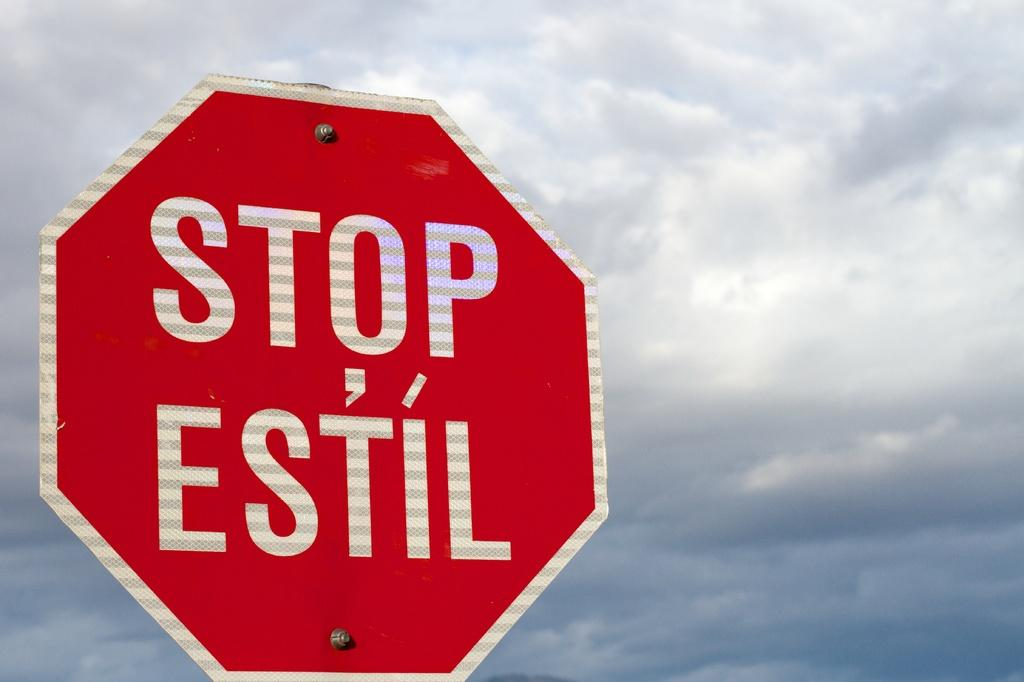<image>
Create a compact narrative representing the image presented. A red sign has the words Stop Estil on it with only clouds seen in the back ground. 